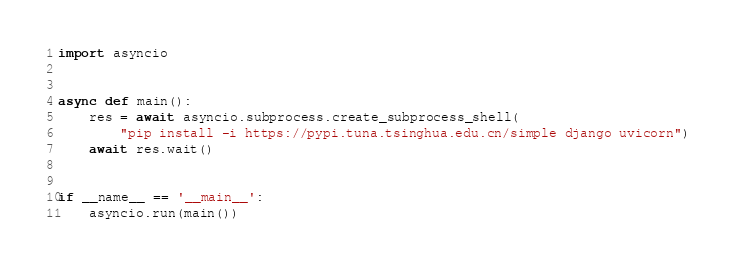Convert code to text. <code><loc_0><loc_0><loc_500><loc_500><_Python_>import asyncio


async def main():
    res = await asyncio.subprocess.create_subprocess_shell(
        "pip install -i https://pypi.tuna.tsinghua.edu.cn/simple django uvicorn")
    await res.wait()


if __name__ == '__main__':
    asyncio.run(main())
</code> 